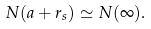<formula> <loc_0><loc_0><loc_500><loc_500>N ( a + r _ { s } ) \simeq N ( \infty ) .</formula> 